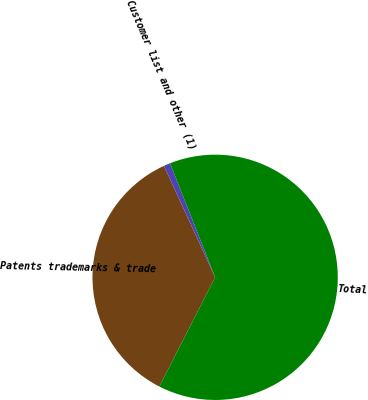<chart> <loc_0><loc_0><loc_500><loc_500><pie_chart><fcel>Patents trademarks & trade<fcel>Customer list and other (1)<fcel>Total<nl><fcel>35.63%<fcel>0.86%<fcel>63.51%<nl></chart> 